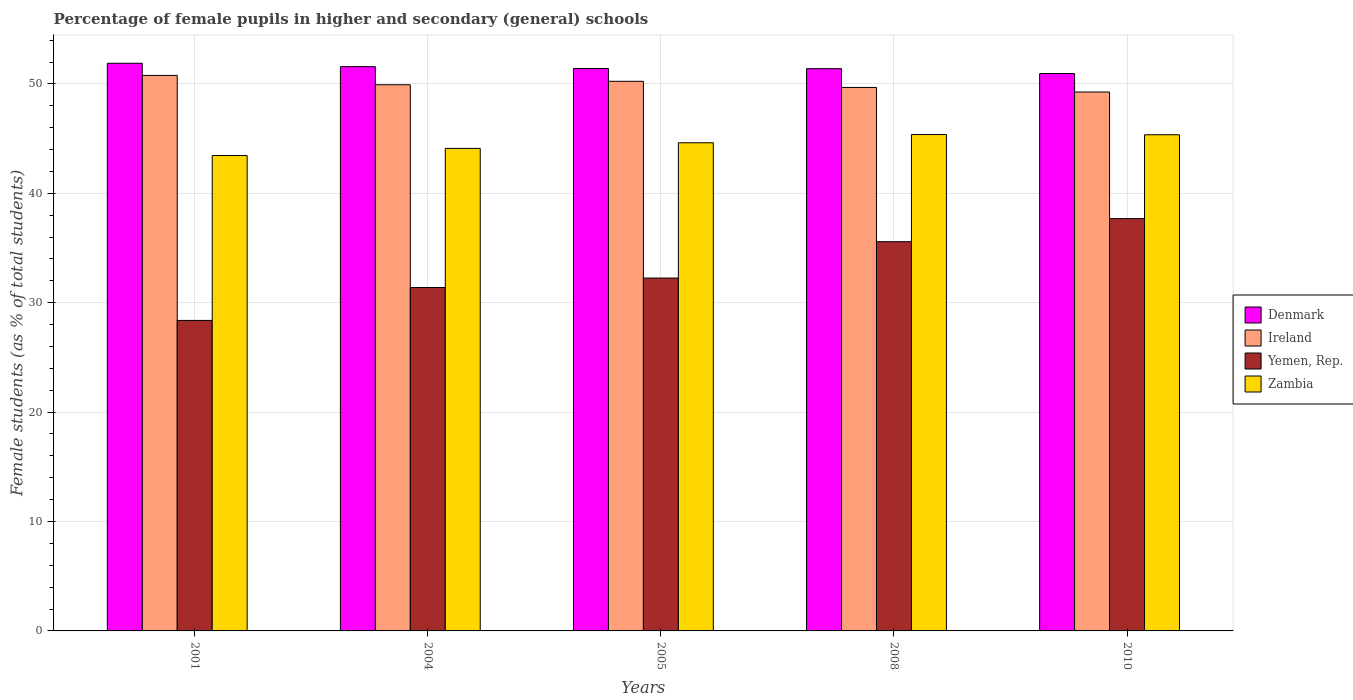How many different coloured bars are there?
Provide a short and direct response. 4. How many groups of bars are there?
Give a very brief answer. 5. How many bars are there on the 2nd tick from the right?
Make the answer very short. 4. What is the label of the 5th group of bars from the left?
Your answer should be very brief. 2010. What is the percentage of female pupils in higher and secondary schools in Zambia in 2010?
Provide a succinct answer. 45.35. Across all years, what is the maximum percentage of female pupils in higher and secondary schools in Zambia?
Offer a terse response. 45.37. Across all years, what is the minimum percentage of female pupils in higher and secondary schools in Zambia?
Make the answer very short. 43.45. In which year was the percentage of female pupils in higher and secondary schools in Zambia maximum?
Provide a short and direct response. 2008. In which year was the percentage of female pupils in higher and secondary schools in Yemen, Rep. minimum?
Offer a terse response. 2001. What is the total percentage of female pupils in higher and secondary schools in Yemen, Rep. in the graph?
Your response must be concise. 165.28. What is the difference between the percentage of female pupils in higher and secondary schools in Zambia in 2005 and that in 2010?
Give a very brief answer. -0.73. What is the difference between the percentage of female pupils in higher and secondary schools in Denmark in 2001 and the percentage of female pupils in higher and secondary schools in Zambia in 2004?
Provide a short and direct response. 7.78. What is the average percentage of female pupils in higher and secondary schools in Ireland per year?
Your response must be concise. 49.97. In the year 2005, what is the difference between the percentage of female pupils in higher and secondary schools in Denmark and percentage of female pupils in higher and secondary schools in Yemen, Rep.?
Your response must be concise. 19.15. What is the ratio of the percentage of female pupils in higher and secondary schools in Ireland in 2004 to that in 2005?
Your answer should be compact. 0.99. Is the percentage of female pupils in higher and secondary schools in Yemen, Rep. in 2005 less than that in 2010?
Offer a terse response. Yes. What is the difference between the highest and the second highest percentage of female pupils in higher and secondary schools in Denmark?
Make the answer very short. 0.31. What is the difference between the highest and the lowest percentage of female pupils in higher and secondary schools in Denmark?
Offer a terse response. 0.94. What does the 4th bar from the left in 2001 represents?
Provide a succinct answer. Zambia. What does the 2nd bar from the right in 2001 represents?
Provide a succinct answer. Yemen, Rep. Is it the case that in every year, the sum of the percentage of female pupils in higher and secondary schools in Yemen, Rep. and percentage of female pupils in higher and secondary schools in Ireland is greater than the percentage of female pupils in higher and secondary schools in Zambia?
Offer a terse response. Yes. Are all the bars in the graph horizontal?
Provide a short and direct response. No. Does the graph contain grids?
Provide a short and direct response. Yes. Where does the legend appear in the graph?
Ensure brevity in your answer.  Center right. How are the legend labels stacked?
Keep it short and to the point. Vertical. What is the title of the graph?
Make the answer very short. Percentage of female pupils in higher and secondary (general) schools. What is the label or title of the Y-axis?
Your answer should be compact. Female students (as % of total students). What is the Female students (as % of total students) in Denmark in 2001?
Keep it short and to the point. 51.89. What is the Female students (as % of total students) of Ireland in 2001?
Ensure brevity in your answer.  50.77. What is the Female students (as % of total students) in Yemen, Rep. in 2001?
Your answer should be very brief. 28.38. What is the Female students (as % of total students) in Zambia in 2001?
Your response must be concise. 43.45. What is the Female students (as % of total students) in Denmark in 2004?
Give a very brief answer. 51.57. What is the Female students (as % of total students) in Ireland in 2004?
Give a very brief answer. 49.92. What is the Female students (as % of total students) in Yemen, Rep. in 2004?
Your answer should be very brief. 31.39. What is the Female students (as % of total students) of Zambia in 2004?
Make the answer very short. 44.1. What is the Female students (as % of total students) of Denmark in 2005?
Provide a succinct answer. 51.41. What is the Female students (as % of total students) in Ireland in 2005?
Give a very brief answer. 50.24. What is the Female students (as % of total students) in Yemen, Rep. in 2005?
Offer a very short reply. 32.25. What is the Female students (as % of total students) in Zambia in 2005?
Ensure brevity in your answer.  44.62. What is the Female students (as % of total students) in Denmark in 2008?
Provide a succinct answer. 51.39. What is the Female students (as % of total students) of Ireland in 2008?
Ensure brevity in your answer.  49.67. What is the Female students (as % of total students) of Yemen, Rep. in 2008?
Offer a terse response. 35.58. What is the Female students (as % of total students) of Zambia in 2008?
Provide a succinct answer. 45.37. What is the Female students (as % of total students) of Denmark in 2010?
Keep it short and to the point. 50.95. What is the Female students (as % of total students) in Ireland in 2010?
Offer a very short reply. 49.26. What is the Female students (as % of total students) of Yemen, Rep. in 2010?
Provide a short and direct response. 37.69. What is the Female students (as % of total students) in Zambia in 2010?
Offer a terse response. 45.35. Across all years, what is the maximum Female students (as % of total students) of Denmark?
Make the answer very short. 51.89. Across all years, what is the maximum Female students (as % of total students) of Ireland?
Your answer should be very brief. 50.77. Across all years, what is the maximum Female students (as % of total students) in Yemen, Rep.?
Your answer should be compact. 37.69. Across all years, what is the maximum Female students (as % of total students) in Zambia?
Make the answer very short. 45.37. Across all years, what is the minimum Female students (as % of total students) of Denmark?
Your response must be concise. 50.95. Across all years, what is the minimum Female students (as % of total students) of Ireland?
Make the answer very short. 49.26. Across all years, what is the minimum Female students (as % of total students) in Yemen, Rep.?
Your answer should be compact. 28.38. Across all years, what is the minimum Female students (as % of total students) of Zambia?
Offer a very short reply. 43.45. What is the total Female students (as % of total students) of Denmark in the graph?
Give a very brief answer. 257.21. What is the total Female students (as % of total students) of Ireland in the graph?
Give a very brief answer. 249.86. What is the total Female students (as % of total students) in Yemen, Rep. in the graph?
Ensure brevity in your answer.  165.28. What is the total Female students (as % of total students) in Zambia in the graph?
Keep it short and to the point. 222.89. What is the difference between the Female students (as % of total students) in Denmark in 2001 and that in 2004?
Your answer should be compact. 0.31. What is the difference between the Female students (as % of total students) in Ireland in 2001 and that in 2004?
Make the answer very short. 0.85. What is the difference between the Female students (as % of total students) of Yemen, Rep. in 2001 and that in 2004?
Keep it short and to the point. -3.01. What is the difference between the Female students (as % of total students) in Zambia in 2001 and that in 2004?
Your answer should be compact. -0.65. What is the difference between the Female students (as % of total students) of Denmark in 2001 and that in 2005?
Offer a very short reply. 0.48. What is the difference between the Female students (as % of total students) in Ireland in 2001 and that in 2005?
Give a very brief answer. 0.54. What is the difference between the Female students (as % of total students) of Yemen, Rep. in 2001 and that in 2005?
Your response must be concise. -3.87. What is the difference between the Female students (as % of total students) in Zambia in 2001 and that in 2005?
Offer a very short reply. -1.17. What is the difference between the Female students (as % of total students) of Denmark in 2001 and that in 2008?
Offer a very short reply. 0.49. What is the difference between the Female students (as % of total students) in Ireland in 2001 and that in 2008?
Provide a short and direct response. 1.1. What is the difference between the Female students (as % of total students) of Yemen, Rep. in 2001 and that in 2008?
Offer a very short reply. -7.2. What is the difference between the Female students (as % of total students) in Zambia in 2001 and that in 2008?
Provide a succinct answer. -1.92. What is the difference between the Female students (as % of total students) in Denmark in 2001 and that in 2010?
Your answer should be very brief. 0.94. What is the difference between the Female students (as % of total students) of Ireland in 2001 and that in 2010?
Offer a terse response. 1.52. What is the difference between the Female students (as % of total students) of Yemen, Rep. in 2001 and that in 2010?
Your answer should be very brief. -9.31. What is the difference between the Female students (as % of total students) in Zambia in 2001 and that in 2010?
Give a very brief answer. -1.9. What is the difference between the Female students (as % of total students) of Denmark in 2004 and that in 2005?
Offer a very short reply. 0.17. What is the difference between the Female students (as % of total students) in Ireland in 2004 and that in 2005?
Provide a short and direct response. -0.31. What is the difference between the Female students (as % of total students) of Yemen, Rep. in 2004 and that in 2005?
Keep it short and to the point. -0.86. What is the difference between the Female students (as % of total students) of Zambia in 2004 and that in 2005?
Offer a very short reply. -0.51. What is the difference between the Female students (as % of total students) of Denmark in 2004 and that in 2008?
Offer a terse response. 0.18. What is the difference between the Female students (as % of total students) of Ireland in 2004 and that in 2008?
Offer a very short reply. 0.25. What is the difference between the Female students (as % of total students) in Yemen, Rep. in 2004 and that in 2008?
Provide a short and direct response. -4.19. What is the difference between the Female students (as % of total students) of Zambia in 2004 and that in 2008?
Provide a succinct answer. -1.27. What is the difference between the Female students (as % of total students) in Denmark in 2004 and that in 2010?
Give a very brief answer. 0.63. What is the difference between the Female students (as % of total students) of Ireland in 2004 and that in 2010?
Your answer should be compact. 0.66. What is the difference between the Female students (as % of total students) of Yemen, Rep. in 2004 and that in 2010?
Offer a very short reply. -6.3. What is the difference between the Female students (as % of total students) of Zambia in 2004 and that in 2010?
Offer a very short reply. -1.25. What is the difference between the Female students (as % of total students) in Denmark in 2005 and that in 2008?
Provide a short and direct response. 0.02. What is the difference between the Female students (as % of total students) in Ireland in 2005 and that in 2008?
Provide a short and direct response. 0.56. What is the difference between the Female students (as % of total students) of Yemen, Rep. in 2005 and that in 2008?
Give a very brief answer. -3.32. What is the difference between the Female students (as % of total students) of Zambia in 2005 and that in 2008?
Ensure brevity in your answer.  -0.75. What is the difference between the Female students (as % of total students) of Denmark in 2005 and that in 2010?
Keep it short and to the point. 0.46. What is the difference between the Female students (as % of total students) in Ireland in 2005 and that in 2010?
Provide a succinct answer. 0.98. What is the difference between the Female students (as % of total students) in Yemen, Rep. in 2005 and that in 2010?
Provide a succinct answer. -5.43. What is the difference between the Female students (as % of total students) of Zambia in 2005 and that in 2010?
Offer a terse response. -0.73. What is the difference between the Female students (as % of total students) of Denmark in 2008 and that in 2010?
Provide a short and direct response. 0.44. What is the difference between the Female students (as % of total students) in Ireland in 2008 and that in 2010?
Offer a very short reply. 0.42. What is the difference between the Female students (as % of total students) in Yemen, Rep. in 2008 and that in 2010?
Your answer should be very brief. -2.11. What is the difference between the Female students (as % of total students) in Zambia in 2008 and that in 2010?
Offer a terse response. 0.02. What is the difference between the Female students (as % of total students) of Denmark in 2001 and the Female students (as % of total students) of Ireland in 2004?
Offer a terse response. 1.97. What is the difference between the Female students (as % of total students) in Denmark in 2001 and the Female students (as % of total students) in Yemen, Rep. in 2004?
Ensure brevity in your answer.  20.5. What is the difference between the Female students (as % of total students) in Denmark in 2001 and the Female students (as % of total students) in Zambia in 2004?
Offer a very short reply. 7.78. What is the difference between the Female students (as % of total students) of Ireland in 2001 and the Female students (as % of total students) of Yemen, Rep. in 2004?
Give a very brief answer. 19.39. What is the difference between the Female students (as % of total students) in Ireland in 2001 and the Female students (as % of total students) in Zambia in 2004?
Your response must be concise. 6.67. What is the difference between the Female students (as % of total students) in Yemen, Rep. in 2001 and the Female students (as % of total students) in Zambia in 2004?
Provide a succinct answer. -15.72. What is the difference between the Female students (as % of total students) in Denmark in 2001 and the Female students (as % of total students) in Ireland in 2005?
Your response must be concise. 1.65. What is the difference between the Female students (as % of total students) in Denmark in 2001 and the Female students (as % of total students) in Yemen, Rep. in 2005?
Your answer should be compact. 19.63. What is the difference between the Female students (as % of total students) in Denmark in 2001 and the Female students (as % of total students) in Zambia in 2005?
Keep it short and to the point. 7.27. What is the difference between the Female students (as % of total students) in Ireland in 2001 and the Female students (as % of total students) in Yemen, Rep. in 2005?
Your answer should be compact. 18.52. What is the difference between the Female students (as % of total students) in Ireland in 2001 and the Female students (as % of total students) in Zambia in 2005?
Offer a very short reply. 6.16. What is the difference between the Female students (as % of total students) of Yemen, Rep. in 2001 and the Female students (as % of total students) of Zambia in 2005?
Give a very brief answer. -16.24. What is the difference between the Female students (as % of total students) of Denmark in 2001 and the Female students (as % of total students) of Ireland in 2008?
Ensure brevity in your answer.  2.21. What is the difference between the Female students (as % of total students) of Denmark in 2001 and the Female students (as % of total students) of Yemen, Rep. in 2008?
Provide a short and direct response. 16.31. What is the difference between the Female students (as % of total students) in Denmark in 2001 and the Female students (as % of total students) in Zambia in 2008?
Offer a very short reply. 6.52. What is the difference between the Female students (as % of total students) of Ireland in 2001 and the Female students (as % of total students) of Yemen, Rep. in 2008?
Offer a very short reply. 15.2. What is the difference between the Female students (as % of total students) in Ireland in 2001 and the Female students (as % of total students) in Zambia in 2008?
Provide a succinct answer. 5.4. What is the difference between the Female students (as % of total students) of Yemen, Rep. in 2001 and the Female students (as % of total students) of Zambia in 2008?
Your response must be concise. -16.99. What is the difference between the Female students (as % of total students) of Denmark in 2001 and the Female students (as % of total students) of Ireland in 2010?
Give a very brief answer. 2.63. What is the difference between the Female students (as % of total students) of Denmark in 2001 and the Female students (as % of total students) of Yemen, Rep. in 2010?
Keep it short and to the point. 14.2. What is the difference between the Female students (as % of total students) in Denmark in 2001 and the Female students (as % of total students) in Zambia in 2010?
Give a very brief answer. 6.54. What is the difference between the Female students (as % of total students) in Ireland in 2001 and the Female students (as % of total students) in Yemen, Rep. in 2010?
Make the answer very short. 13.09. What is the difference between the Female students (as % of total students) in Ireland in 2001 and the Female students (as % of total students) in Zambia in 2010?
Make the answer very short. 5.42. What is the difference between the Female students (as % of total students) of Yemen, Rep. in 2001 and the Female students (as % of total students) of Zambia in 2010?
Your response must be concise. -16.97. What is the difference between the Female students (as % of total students) in Denmark in 2004 and the Female students (as % of total students) in Ireland in 2005?
Your response must be concise. 1.34. What is the difference between the Female students (as % of total students) in Denmark in 2004 and the Female students (as % of total students) in Yemen, Rep. in 2005?
Offer a terse response. 19.32. What is the difference between the Female students (as % of total students) in Denmark in 2004 and the Female students (as % of total students) in Zambia in 2005?
Offer a very short reply. 6.96. What is the difference between the Female students (as % of total students) of Ireland in 2004 and the Female students (as % of total students) of Yemen, Rep. in 2005?
Offer a terse response. 17.67. What is the difference between the Female students (as % of total students) in Ireland in 2004 and the Female students (as % of total students) in Zambia in 2005?
Offer a terse response. 5.3. What is the difference between the Female students (as % of total students) in Yemen, Rep. in 2004 and the Female students (as % of total students) in Zambia in 2005?
Your answer should be very brief. -13.23. What is the difference between the Female students (as % of total students) of Denmark in 2004 and the Female students (as % of total students) of Ireland in 2008?
Offer a terse response. 1.9. What is the difference between the Female students (as % of total students) of Denmark in 2004 and the Female students (as % of total students) of Yemen, Rep. in 2008?
Provide a short and direct response. 16. What is the difference between the Female students (as % of total students) in Denmark in 2004 and the Female students (as % of total students) in Zambia in 2008?
Provide a short and direct response. 6.21. What is the difference between the Female students (as % of total students) in Ireland in 2004 and the Female students (as % of total students) in Yemen, Rep. in 2008?
Make the answer very short. 14.34. What is the difference between the Female students (as % of total students) of Ireland in 2004 and the Female students (as % of total students) of Zambia in 2008?
Provide a short and direct response. 4.55. What is the difference between the Female students (as % of total students) in Yemen, Rep. in 2004 and the Female students (as % of total students) in Zambia in 2008?
Offer a terse response. -13.98. What is the difference between the Female students (as % of total students) of Denmark in 2004 and the Female students (as % of total students) of Ireland in 2010?
Your answer should be very brief. 2.32. What is the difference between the Female students (as % of total students) in Denmark in 2004 and the Female students (as % of total students) in Yemen, Rep. in 2010?
Your response must be concise. 13.89. What is the difference between the Female students (as % of total students) of Denmark in 2004 and the Female students (as % of total students) of Zambia in 2010?
Keep it short and to the point. 6.23. What is the difference between the Female students (as % of total students) of Ireland in 2004 and the Female students (as % of total students) of Yemen, Rep. in 2010?
Provide a succinct answer. 12.23. What is the difference between the Female students (as % of total students) of Ireland in 2004 and the Female students (as % of total students) of Zambia in 2010?
Offer a very short reply. 4.57. What is the difference between the Female students (as % of total students) in Yemen, Rep. in 2004 and the Female students (as % of total students) in Zambia in 2010?
Offer a very short reply. -13.96. What is the difference between the Female students (as % of total students) of Denmark in 2005 and the Female students (as % of total students) of Ireland in 2008?
Keep it short and to the point. 1.73. What is the difference between the Female students (as % of total students) in Denmark in 2005 and the Female students (as % of total students) in Yemen, Rep. in 2008?
Make the answer very short. 15.83. What is the difference between the Female students (as % of total students) of Denmark in 2005 and the Female students (as % of total students) of Zambia in 2008?
Offer a very short reply. 6.04. What is the difference between the Female students (as % of total students) in Ireland in 2005 and the Female students (as % of total students) in Yemen, Rep. in 2008?
Offer a very short reply. 14.66. What is the difference between the Female students (as % of total students) of Ireland in 2005 and the Female students (as % of total students) of Zambia in 2008?
Keep it short and to the point. 4.87. What is the difference between the Female students (as % of total students) in Yemen, Rep. in 2005 and the Female students (as % of total students) in Zambia in 2008?
Make the answer very short. -13.12. What is the difference between the Female students (as % of total students) of Denmark in 2005 and the Female students (as % of total students) of Ireland in 2010?
Keep it short and to the point. 2.15. What is the difference between the Female students (as % of total students) in Denmark in 2005 and the Female students (as % of total students) in Yemen, Rep. in 2010?
Provide a short and direct response. 13.72. What is the difference between the Female students (as % of total students) in Denmark in 2005 and the Female students (as % of total students) in Zambia in 2010?
Give a very brief answer. 6.06. What is the difference between the Female students (as % of total students) in Ireland in 2005 and the Female students (as % of total students) in Yemen, Rep. in 2010?
Offer a very short reply. 12.55. What is the difference between the Female students (as % of total students) of Ireland in 2005 and the Female students (as % of total students) of Zambia in 2010?
Your response must be concise. 4.89. What is the difference between the Female students (as % of total students) in Yemen, Rep. in 2005 and the Female students (as % of total students) in Zambia in 2010?
Keep it short and to the point. -13.1. What is the difference between the Female students (as % of total students) in Denmark in 2008 and the Female students (as % of total students) in Ireland in 2010?
Make the answer very short. 2.14. What is the difference between the Female students (as % of total students) of Denmark in 2008 and the Female students (as % of total students) of Yemen, Rep. in 2010?
Ensure brevity in your answer.  13.71. What is the difference between the Female students (as % of total students) in Denmark in 2008 and the Female students (as % of total students) in Zambia in 2010?
Offer a very short reply. 6.04. What is the difference between the Female students (as % of total students) of Ireland in 2008 and the Female students (as % of total students) of Yemen, Rep. in 2010?
Provide a short and direct response. 11.99. What is the difference between the Female students (as % of total students) in Ireland in 2008 and the Female students (as % of total students) in Zambia in 2010?
Give a very brief answer. 4.32. What is the difference between the Female students (as % of total students) in Yemen, Rep. in 2008 and the Female students (as % of total students) in Zambia in 2010?
Offer a terse response. -9.77. What is the average Female students (as % of total students) of Denmark per year?
Provide a succinct answer. 51.44. What is the average Female students (as % of total students) of Ireland per year?
Keep it short and to the point. 49.97. What is the average Female students (as % of total students) of Yemen, Rep. per year?
Keep it short and to the point. 33.06. What is the average Female students (as % of total students) in Zambia per year?
Your answer should be very brief. 44.58. In the year 2001, what is the difference between the Female students (as % of total students) of Denmark and Female students (as % of total students) of Ireland?
Your answer should be very brief. 1.11. In the year 2001, what is the difference between the Female students (as % of total students) in Denmark and Female students (as % of total students) in Yemen, Rep.?
Provide a short and direct response. 23.51. In the year 2001, what is the difference between the Female students (as % of total students) of Denmark and Female students (as % of total students) of Zambia?
Keep it short and to the point. 8.44. In the year 2001, what is the difference between the Female students (as % of total students) of Ireland and Female students (as % of total students) of Yemen, Rep.?
Give a very brief answer. 22.39. In the year 2001, what is the difference between the Female students (as % of total students) in Ireland and Female students (as % of total students) in Zambia?
Provide a short and direct response. 7.32. In the year 2001, what is the difference between the Female students (as % of total students) of Yemen, Rep. and Female students (as % of total students) of Zambia?
Your response must be concise. -15.07. In the year 2004, what is the difference between the Female students (as % of total students) in Denmark and Female students (as % of total students) in Ireland?
Your response must be concise. 1.65. In the year 2004, what is the difference between the Female students (as % of total students) of Denmark and Female students (as % of total students) of Yemen, Rep.?
Make the answer very short. 20.19. In the year 2004, what is the difference between the Female students (as % of total students) in Denmark and Female students (as % of total students) in Zambia?
Provide a succinct answer. 7.47. In the year 2004, what is the difference between the Female students (as % of total students) of Ireland and Female students (as % of total students) of Yemen, Rep.?
Give a very brief answer. 18.53. In the year 2004, what is the difference between the Female students (as % of total students) of Ireland and Female students (as % of total students) of Zambia?
Provide a short and direct response. 5.82. In the year 2004, what is the difference between the Female students (as % of total students) in Yemen, Rep. and Female students (as % of total students) in Zambia?
Provide a short and direct response. -12.72. In the year 2005, what is the difference between the Female students (as % of total students) of Denmark and Female students (as % of total students) of Ireland?
Your answer should be compact. 1.17. In the year 2005, what is the difference between the Female students (as % of total students) in Denmark and Female students (as % of total students) in Yemen, Rep.?
Provide a short and direct response. 19.16. In the year 2005, what is the difference between the Female students (as % of total students) of Denmark and Female students (as % of total students) of Zambia?
Provide a succinct answer. 6.79. In the year 2005, what is the difference between the Female students (as % of total students) in Ireland and Female students (as % of total students) in Yemen, Rep.?
Give a very brief answer. 17.98. In the year 2005, what is the difference between the Female students (as % of total students) in Ireland and Female students (as % of total students) in Zambia?
Offer a terse response. 5.62. In the year 2005, what is the difference between the Female students (as % of total students) of Yemen, Rep. and Female students (as % of total students) of Zambia?
Offer a terse response. -12.36. In the year 2008, what is the difference between the Female students (as % of total students) in Denmark and Female students (as % of total students) in Ireland?
Offer a terse response. 1.72. In the year 2008, what is the difference between the Female students (as % of total students) of Denmark and Female students (as % of total students) of Yemen, Rep.?
Give a very brief answer. 15.82. In the year 2008, what is the difference between the Female students (as % of total students) in Denmark and Female students (as % of total students) in Zambia?
Keep it short and to the point. 6.02. In the year 2008, what is the difference between the Female students (as % of total students) in Ireland and Female students (as % of total students) in Yemen, Rep.?
Your answer should be compact. 14.1. In the year 2008, what is the difference between the Female students (as % of total students) of Ireland and Female students (as % of total students) of Zambia?
Make the answer very short. 4.3. In the year 2008, what is the difference between the Female students (as % of total students) of Yemen, Rep. and Female students (as % of total students) of Zambia?
Provide a short and direct response. -9.79. In the year 2010, what is the difference between the Female students (as % of total students) in Denmark and Female students (as % of total students) in Ireland?
Your answer should be very brief. 1.69. In the year 2010, what is the difference between the Female students (as % of total students) in Denmark and Female students (as % of total students) in Yemen, Rep.?
Provide a succinct answer. 13.26. In the year 2010, what is the difference between the Female students (as % of total students) in Denmark and Female students (as % of total students) in Zambia?
Ensure brevity in your answer.  5.6. In the year 2010, what is the difference between the Female students (as % of total students) in Ireland and Female students (as % of total students) in Yemen, Rep.?
Make the answer very short. 11.57. In the year 2010, what is the difference between the Female students (as % of total students) of Ireland and Female students (as % of total students) of Zambia?
Make the answer very short. 3.91. In the year 2010, what is the difference between the Female students (as % of total students) of Yemen, Rep. and Female students (as % of total students) of Zambia?
Give a very brief answer. -7.66. What is the ratio of the Female students (as % of total students) of Denmark in 2001 to that in 2004?
Your answer should be very brief. 1.01. What is the ratio of the Female students (as % of total students) of Ireland in 2001 to that in 2004?
Offer a very short reply. 1.02. What is the ratio of the Female students (as % of total students) of Yemen, Rep. in 2001 to that in 2004?
Ensure brevity in your answer.  0.9. What is the ratio of the Female students (as % of total students) in Zambia in 2001 to that in 2004?
Ensure brevity in your answer.  0.99. What is the ratio of the Female students (as % of total students) of Denmark in 2001 to that in 2005?
Keep it short and to the point. 1.01. What is the ratio of the Female students (as % of total students) of Ireland in 2001 to that in 2005?
Make the answer very short. 1.01. What is the ratio of the Female students (as % of total students) in Yemen, Rep. in 2001 to that in 2005?
Your response must be concise. 0.88. What is the ratio of the Female students (as % of total students) in Zambia in 2001 to that in 2005?
Provide a succinct answer. 0.97. What is the ratio of the Female students (as % of total students) in Denmark in 2001 to that in 2008?
Offer a terse response. 1.01. What is the ratio of the Female students (as % of total students) of Ireland in 2001 to that in 2008?
Your answer should be compact. 1.02. What is the ratio of the Female students (as % of total students) in Yemen, Rep. in 2001 to that in 2008?
Offer a very short reply. 0.8. What is the ratio of the Female students (as % of total students) of Zambia in 2001 to that in 2008?
Keep it short and to the point. 0.96. What is the ratio of the Female students (as % of total students) in Denmark in 2001 to that in 2010?
Provide a succinct answer. 1.02. What is the ratio of the Female students (as % of total students) in Ireland in 2001 to that in 2010?
Your answer should be very brief. 1.03. What is the ratio of the Female students (as % of total students) of Yemen, Rep. in 2001 to that in 2010?
Your answer should be very brief. 0.75. What is the ratio of the Female students (as % of total students) of Zambia in 2001 to that in 2010?
Your answer should be very brief. 0.96. What is the ratio of the Female students (as % of total students) of Denmark in 2004 to that in 2005?
Ensure brevity in your answer.  1. What is the ratio of the Female students (as % of total students) of Yemen, Rep. in 2004 to that in 2005?
Give a very brief answer. 0.97. What is the ratio of the Female students (as % of total students) in Zambia in 2004 to that in 2005?
Make the answer very short. 0.99. What is the ratio of the Female students (as % of total students) in Yemen, Rep. in 2004 to that in 2008?
Give a very brief answer. 0.88. What is the ratio of the Female students (as % of total students) of Zambia in 2004 to that in 2008?
Give a very brief answer. 0.97. What is the ratio of the Female students (as % of total students) in Denmark in 2004 to that in 2010?
Keep it short and to the point. 1.01. What is the ratio of the Female students (as % of total students) of Ireland in 2004 to that in 2010?
Provide a short and direct response. 1.01. What is the ratio of the Female students (as % of total students) in Yemen, Rep. in 2004 to that in 2010?
Keep it short and to the point. 0.83. What is the ratio of the Female students (as % of total students) in Zambia in 2004 to that in 2010?
Provide a succinct answer. 0.97. What is the ratio of the Female students (as % of total students) of Denmark in 2005 to that in 2008?
Offer a terse response. 1. What is the ratio of the Female students (as % of total students) of Ireland in 2005 to that in 2008?
Offer a very short reply. 1.01. What is the ratio of the Female students (as % of total students) of Yemen, Rep. in 2005 to that in 2008?
Provide a succinct answer. 0.91. What is the ratio of the Female students (as % of total students) in Zambia in 2005 to that in 2008?
Your answer should be very brief. 0.98. What is the ratio of the Female students (as % of total students) of Ireland in 2005 to that in 2010?
Keep it short and to the point. 1.02. What is the ratio of the Female students (as % of total students) of Yemen, Rep. in 2005 to that in 2010?
Your answer should be compact. 0.86. What is the ratio of the Female students (as % of total students) in Zambia in 2005 to that in 2010?
Give a very brief answer. 0.98. What is the ratio of the Female students (as % of total students) of Denmark in 2008 to that in 2010?
Keep it short and to the point. 1.01. What is the ratio of the Female students (as % of total students) of Ireland in 2008 to that in 2010?
Keep it short and to the point. 1.01. What is the ratio of the Female students (as % of total students) in Yemen, Rep. in 2008 to that in 2010?
Provide a short and direct response. 0.94. What is the difference between the highest and the second highest Female students (as % of total students) in Denmark?
Provide a short and direct response. 0.31. What is the difference between the highest and the second highest Female students (as % of total students) in Ireland?
Your response must be concise. 0.54. What is the difference between the highest and the second highest Female students (as % of total students) of Yemen, Rep.?
Offer a terse response. 2.11. What is the difference between the highest and the second highest Female students (as % of total students) of Zambia?
Provide a short and direct response. 0.02. What is the difference between the highest and the lowest Female students (as % of total students) in Denmark?
Your response must be concise. 0.94. What is the difference between the highest and the lowest Female students (as % of total students) in Ireland?
Your answer should be very brief. 1.52. What is the difference between the highest and the lowest Female students (as % of total students) in Yemen, Rep.?
Your answer should be compact. 9.31. What is the difference between the highest and the lowest Female students (as % of total students) in Zambia?
Make the answer very short. 1.92. 